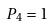Convert formula to latex. <formula><loc_0><loc_0><loc_500><loc_500>P _ { 4 } = 1</formula> 